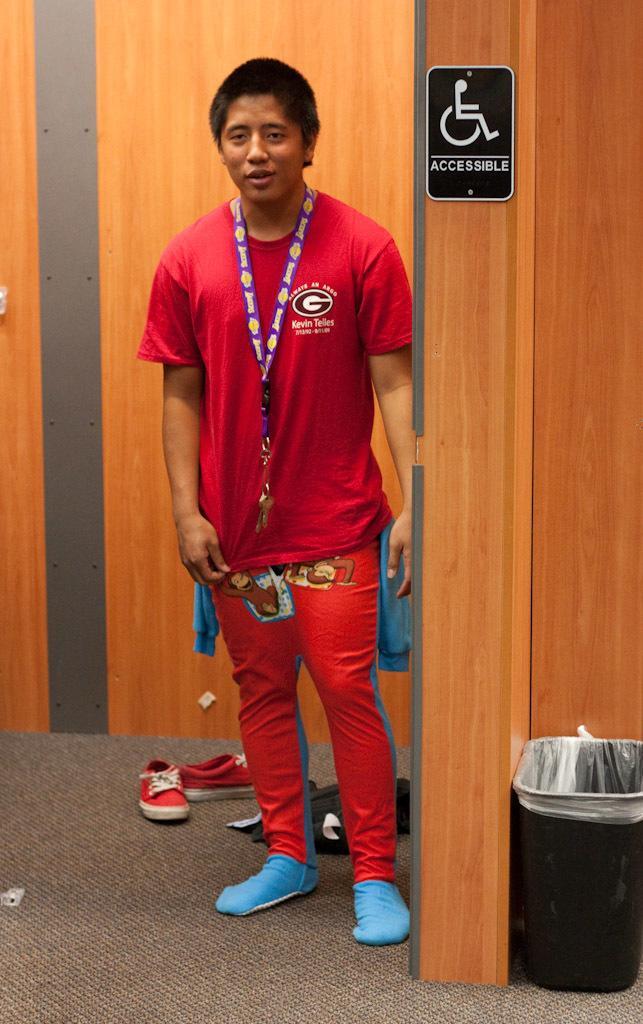Could you give a brief overview of what you see in this image? In this image I see a man who is standing and I see that he is wearing red and orange color dress and I see the shoes over here and I see a trash can over here and I see the wall which is of brown in color and I see something is written on this black color board. 